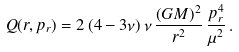Convert formula to latex. <formula><loc_0><loc_0><loc_500><loc_500>Q ( r , p _ { r } ) = 2 \, ( 4 - 3 \nu ) \, \nu \, \frac { ( G M ) ^ { 2 } } { r ^ { 2 } } \, \frac { p _ { r } ^ { 4 } } { \mu ^ { 2 } } \, .</formula> 